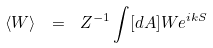<formula> <loc_0><loc_0><loc_500><loc_500>\langle W \rangle \ = \ Z ^ { - 1 } \int [ d A ] W e ^ { i k S }</formula> 